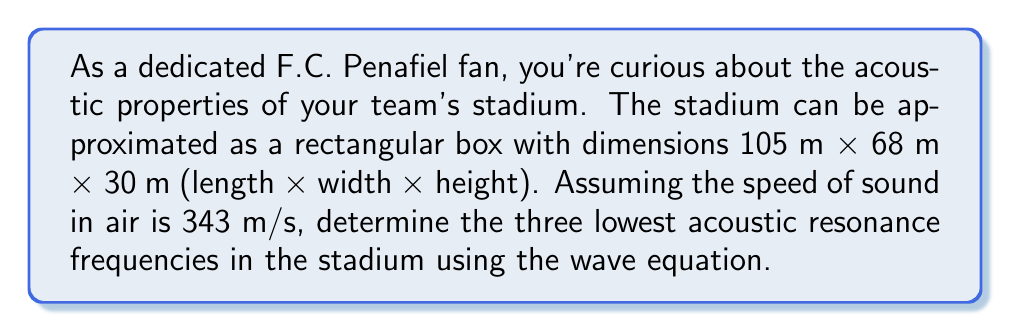Teach me how to tackle this problem. To solve this problem, we'll use the wave equation for a rectangular cavity:

$$\frac{\partial^2 p}{\partial x^2} + \frac{\partial^2 p}{\partial y^2} + \frac{\partial^2 p}{\partial z^2} = \frac{1}{c^2}\frac{\partial^2 p}{\partial t^2}$$

Where $p$ is the acoustic pressure, $c$ is the speed of sound, and $x$, $y$, and $z$ are the spatial coordinates.

The solution for the resonance frequencies in a rectangular cavity is given by:

$$f_{nml} = \frac{c}{2}\sqrt{\left(\frac{n}{L_x}\right)^2 + \left(\frac{m}{L_y}\right)^2 + \left(\frac{l}{L_z}\right)^2}$$

Where:
- $f_{nml}$ is the resonance frequency
- $n$, $m$, and $l$ are non-negative integers (not all zero)
- $L_x$, $L_y$, and $L_z$ are the dimensions of the cavity

Given:
- $L_x = 105$ m (length)
- $L_y = 68$ m (width)
- $L_z = 30$ m (height)
- $c = 343$ m/s (speed of sound)

Let's calculate the three lowest frequencies:

1. $f_{100}$ (1,0,0 mode):
   $$f_{100} = \frac{343}{2}\sqrt{\left(\frac{1}{105}\right)^2 + 0^2 + 0^2} = 1.63 \text{ Hz}$$

2. $f_{010}$ (0,1,0 mode):
   $$f_{010} = \frac{343}{2}\sqrt{0^2 + \left(\frac{1}{68}\right)^2 + 0^2} = 2.52 \text{ Hz}$$

3. $f_{001}$ (0,0,1 mode):
   $$f_{001} = \frac{343}{2}\sqrt{0^2 + 0^2 + \left(\frac{1}{30}\right)^2} = 5.72 \text{ Hz}$$

These are the three lowest acoustic resonance frequencies in the F.C. Penafiel stadium.
Answer: 1.63 Hz, 2.52 Hz, 5.72 Hz 